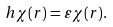Convert formula to latex. <formula><loc_0><loc_0><loc_500><loc_500>h \chi ( { r } ) = \varepsilon \chi ( { r } ) .</formula> 